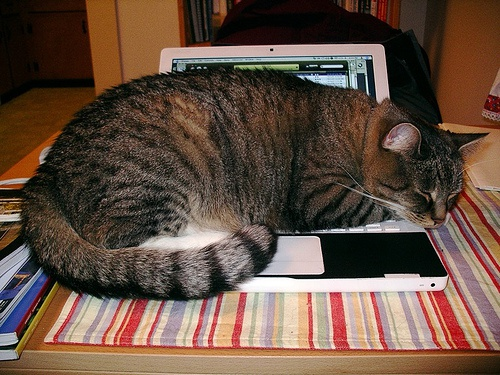Describe the objects in this image and their specific colors. I can see cat in black, gray, and maroon tones, laptop in black, lightgray, and darkgray tones, book in black, darkgray, navy, and gray tones, book in black, olive, and darkgray tones, and book in black, maroon, darkgray, and lightgray tones in this image. 